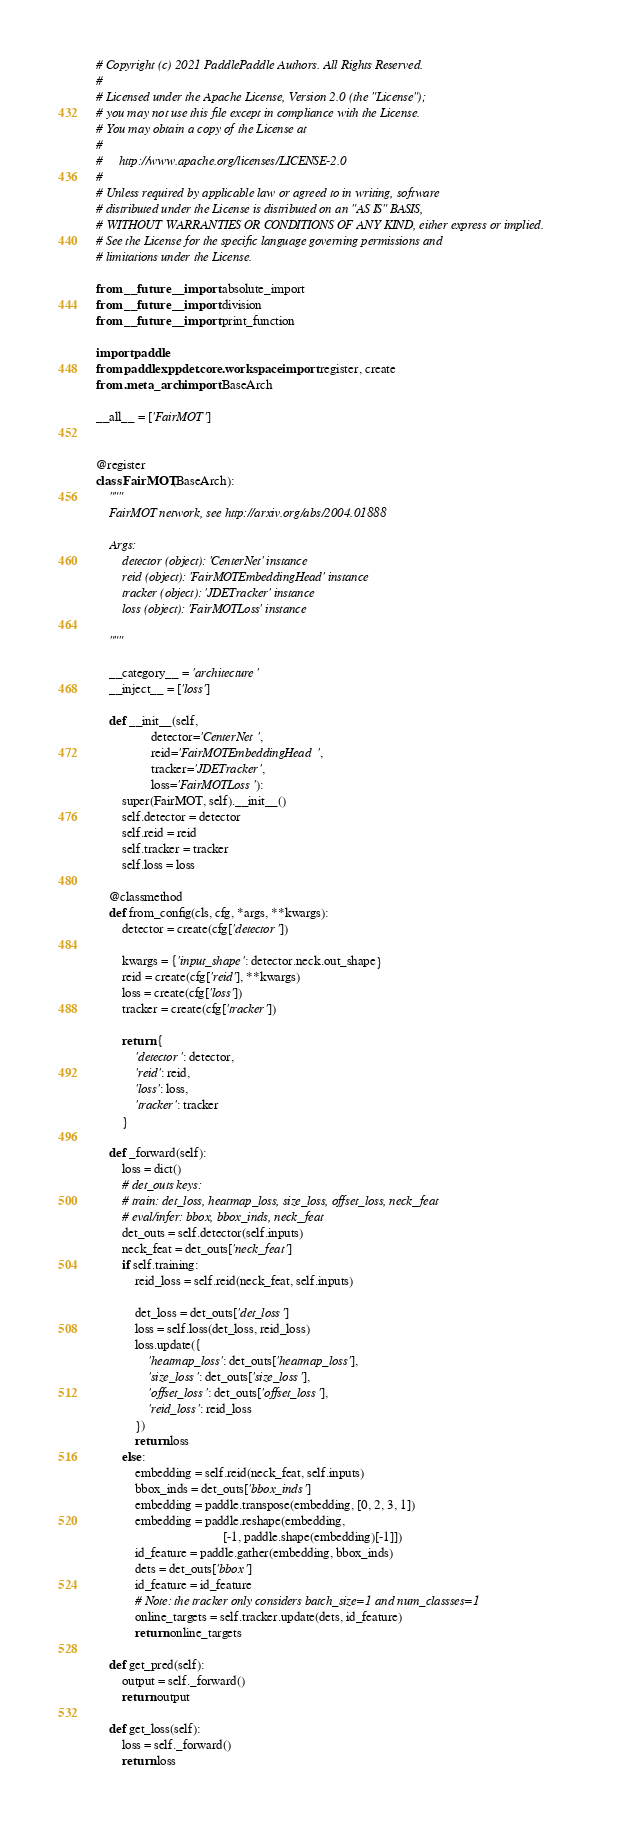Convert code to text. <code><loc_0><loc_0><loc_500><loc_500><_Python_># Copyright (c) 2021 PaddlePaddle Authors. All Rights Reserved. 
#   
# Licensed under the Apache License, Version 2.0 (the "License");   
# you may not use this file except in compliance with the License.  
# You may obtain a copy of the License at   
#   
#     http://www.apache.org/licenses/LICENSE-2.0    
#   
# Unless required by applicable law or agreed to in writing, software   
# distributed under the License is distributed on an "AS IS" BASIS, 
# WITHOUT WARRANTIES OR CONDITIONS OF ANY KIND, either express or implied.  
# See the License for the specific language governing permissions and   
# limitations under the License.

from __future__ import absolute_import
from __future__ import division
from __future__ import print_function

import paddle
from paddlex.ppdet.core.workspace import register, create
from .meta_arch import BaseArch

__all__ = ['FairMOT']


@register
class FairMOT(BaseArch):
    """
    FairMOT network, see http://arxiv.org/abs/2004.01888

    Args:
        detector (object): 'CenterNet' instance
        reid (object): 'FairMOTEmbeddingHead' instance
        tracker (object): 'JDETracker' instance
        loss (object): 'FairMOTLoss' instance

    """

    __category__ = 'architecture'
    __inject__ = ['loss']

    def __init__(self,
                 detector='CenterNet',
                 reid='FairMOTEmbeddingHead',
                 tracker='JDETracker',
                 loss='FairMOTLoss'):
        super(FairMOT, self).__init__()
        self.detector = detector
        self.reid = reid
        self.tracker = tracker
        self.loss = loss

    @classmethod
    def from_config(cls, cfg, *args, **kwargs):
        detector = create(cfg['detector'])

        kwargs = {'input_shape': detector.neck.out_shape}
        reid = create(cfg['reid'], **kwargs)
        loss = create(cfg['loss'])
        tracker = create(cfg['tracker'])

        return {
            'detector': detector,
            'reid': reid,
            'loss': loss,
            'tracker': tracker
        }

    def _forward(self):
        loss = dict()
        # det_outs keys:
        # train: det_loss, heatmap_loss, size_loss, offset_loss, neck_feat
        # eval/infer: bbox, bbox_inds, neck_feat
        det_outs = self.detector(self.inputs)
        neck_feat = det_outs['neck_feat']
        if self.training:
            reid_loss = self.reid(neck_feat, self.inputs)

            det_loss = det_outs['det_loss']
            loss = self.loss(det_loss, reid_loss)
            loss.update({
                'heatmap_loss': det_outs['heatmap_loss'],
                'size_loss': det_outs['size_loss'],
                'offset_loss': det_outs['offset_loss'],
                'reid_loss': reid_loss
            })
            return loss
        else:
            embedding = self.reid(neck_feat, self.inputs)
            bbox_inds = det_outs['bbox_inds']
            embedding = paddle.transpose(embedding, [0, 2, 3, 1])
            embedding = paddle.reshape(embedding,
                                       [-1, paddle.shape(embedding)[-1]])
            id_feature = paddle.gather(embedding, bbox_inds)
            dets = det_outs['bbox']
            id_feature = id_feature
            # Note: the tracker only considers batch_size=1 and num_classses=1
            online_targets = self.tracker.update(dets, id_feature)
            return online_targets

    def get_pred(self):
        output = self._forward()
        return output

    def get_loss(self):
        loss = self._forward()
        return loss
</code> 